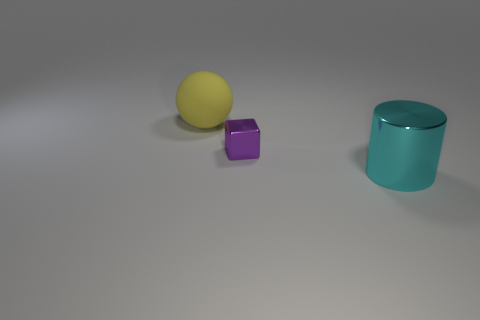Is there anything else that is the same shape as the tiny object?
Provide a short and direct response. No. There is a yellow object; is it the same size as the metallic object that is behind the cyan cylinder?
Make the answer very short. No. How many other things are the same size as the sphere?
Your answer should be compact. 1. Is there anything else that is the same size as the cube?
Offer a very short reply. No. How many other things are there of the same shape as the small purple object?
Ensure brevity in your answer.  0. Do the cyan object and the yellow object have the same size?
Make the answer very short. Yes. Are there any tiny red metallic spheres?
Your response must be concise. No. Is there any other thing that has the same material as the big yellow object?
Ensure brevity in your answer.  No. Are there any cyan cylinders made of the same material as the yellow thing?
Give a very brief answer. No. What is the material of the cyan cylinder that is the same size as the yellow sphere?
Your response must be concise. Metal. 